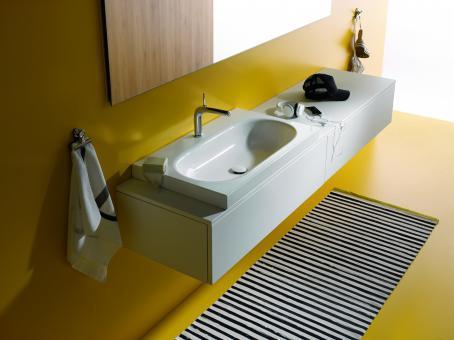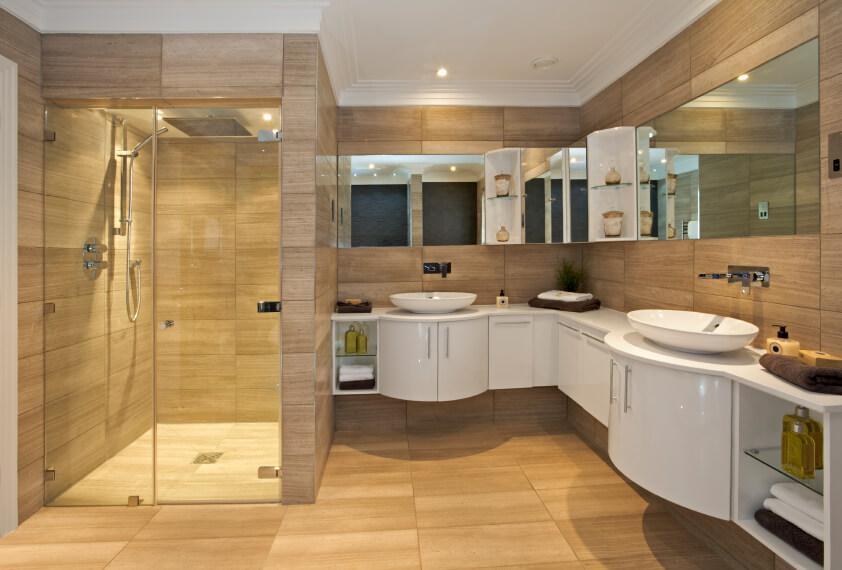The first image is the image on the left, the second image is the image on the right. Examine the images to the left and right. Is the description "One of the images displays more than one sink." accurate? Answer yes or no. Yes. The first image is the image on the left, the second image is the image on the right. Assess this claim about the two images: "A mirror is on a yellow wall above a white sink in one bathroom.". Correct or not? Answer yes or no. Yes. 